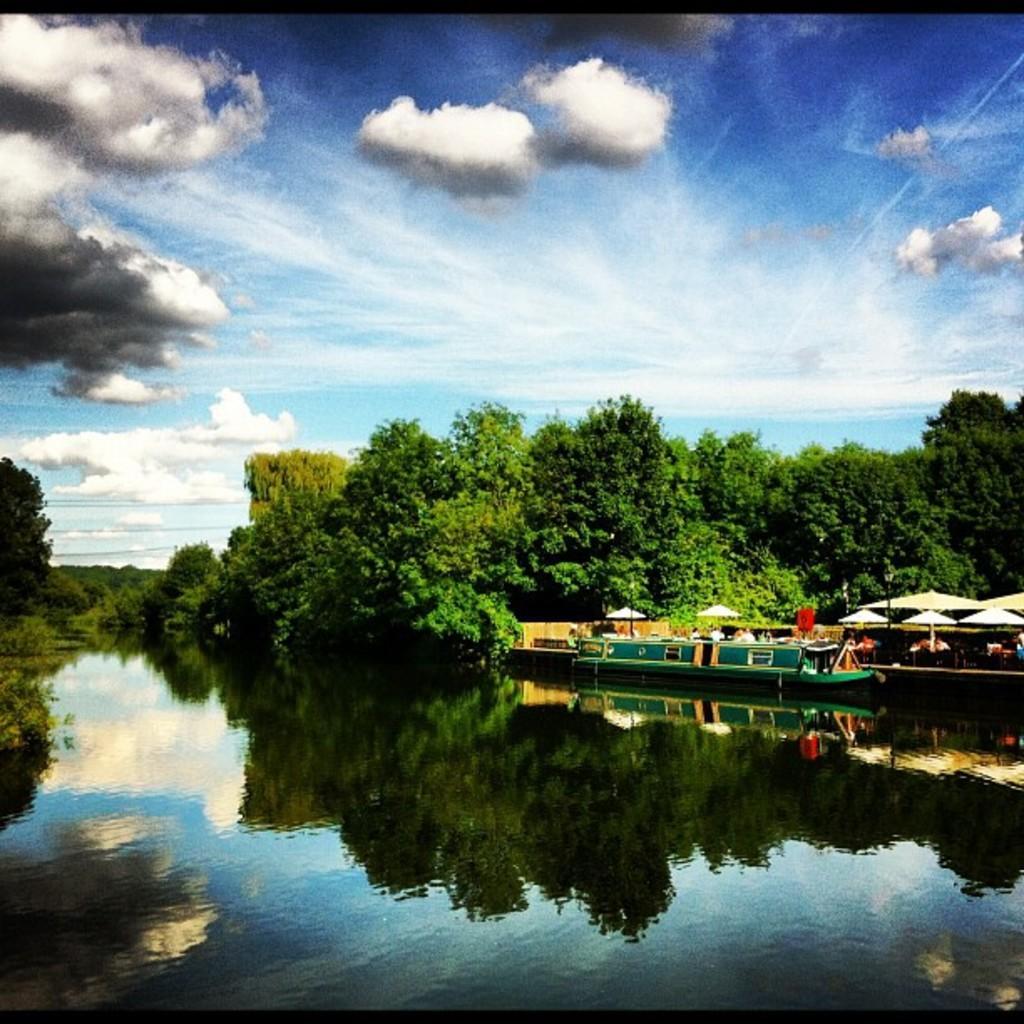Please provide a concise description of this image. This is an edited picture. I can see a boat on the water, there are group of people, there are umbrellas with poles, there are trees, and in the background there is the sky. 